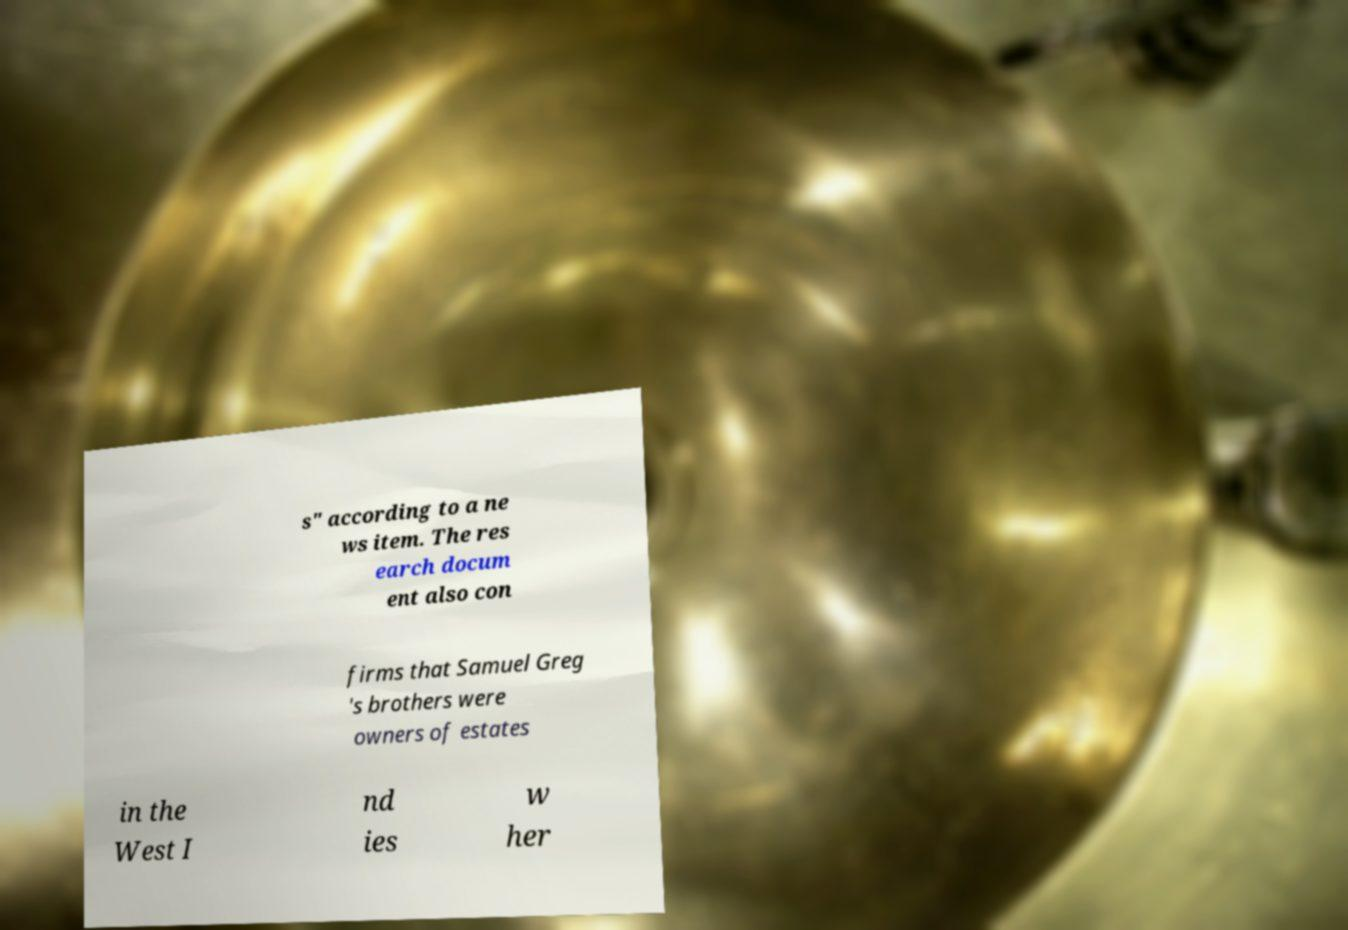Please identify and transcribe the text found in this image. s" according to a ne ws item. The res earch docum ent also con firms that Samuel Greg 's brothers were owners of estates in the West I nd ies w her 